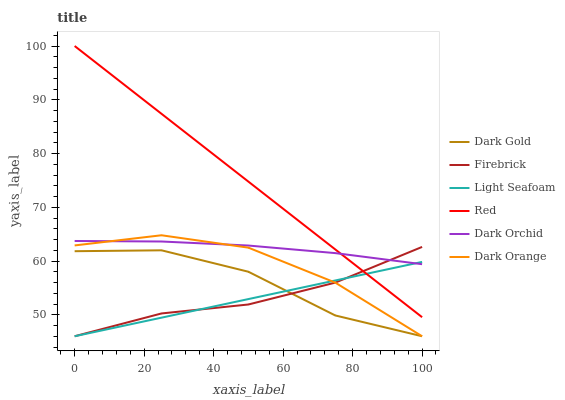Does Light Seafoam have the minimum area under the curve?
Answer yes or no. Yes. Does Red have the maximum area under the curve?
Answer yes or no. Yes. Does Dark Gold have the minimum area under the curve?
Answer yes or no. No. Does Dark Gold have the maximum area under the curve?
Answer yes or no. No. Is Light Seafoam the smoothest?
Answer yes or no. Yes. Is Dark Gold the roughest?
Answer yes or no. Yes. Is Firebrick the smoothest?
Answer yes or no. No. Is Firebrick the roughest?
Answer yes or no. No. Does Dark Orange have the lowest value?
Answer yes or no. Yes. Does Dark Orchid have the lowest value?
Answer yes or no. No. Does Red have the highest value?
Answer yes or no. Yes. Does Dark Gold have the highest value?
Answer yes or no. No. Is Dark Gold less than Dark Orchid?
Answer yes or no. Yes. Is Dark Orchid greater than Dark Gold?
Answer yes or no. Yes. Does Dark Orchid intersect Dark Orange?
Answer yes or no. Yes. Is Dark Orchid less than Dark Orange?
Answer yes or no. No. Is Dark Orchid greater than Dark Orange?
Answer yes or no. No. Does Dark Gold intersect Dark Orchid?
Answer yes or no. No. 